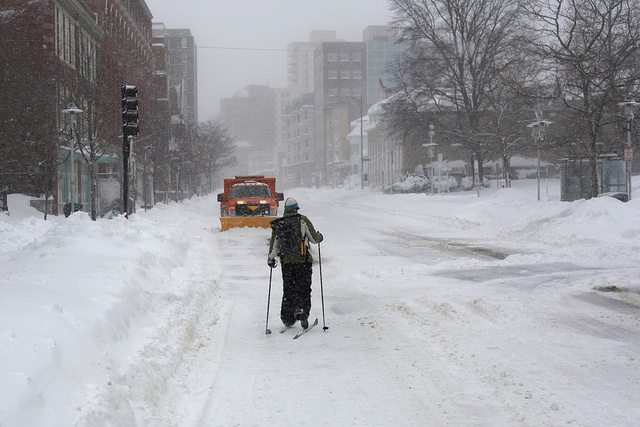Describe the objects in this image and their specific colors. I can see people in black, gray, darkgray, and lightgray tones, truck in black, gray, and brown tones, traffic light in black, gray, and darkgray tones, backpack in black, gray, and maroon tones, and skis in black, gray, and darkgray tones in this image. 